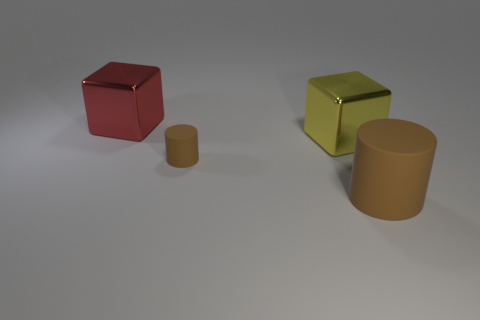There is a cylinder that is the same color as the small rubber object; what size is it?
Your answer should be compact. Large. Are there any other things of the same color as the small thing?
Your response must be concise. Yes. The large red thing has what shape?
Your answer should be compact. Cube. There is a small object that is the same material as the big brown cylinder; what is its color?
Your response must be concise. Brown. Are there more cyan metallic blocks than big brown things?
Your answer should be compact. No. Is there a brown matte thing?
Give a very brief answer. Yes. There is a rubber object that is left of the metal block right of the big red metallic block; what shape is it?
Offer a very short reply. Cylinder. How many objects are tiny gray rubber objects or large things that are in front of the big yellow metal cube?
Keep it short and to the point. 1. There is a matte cylinder right of the matte cylinder on the left side of the brown object in front of the small cylinder; what color is it?
Your answer should be compact. Brown. There is a big yellow object that is the same shape as the big red object; what is it made of?
Your answer should be compact. Metal. 